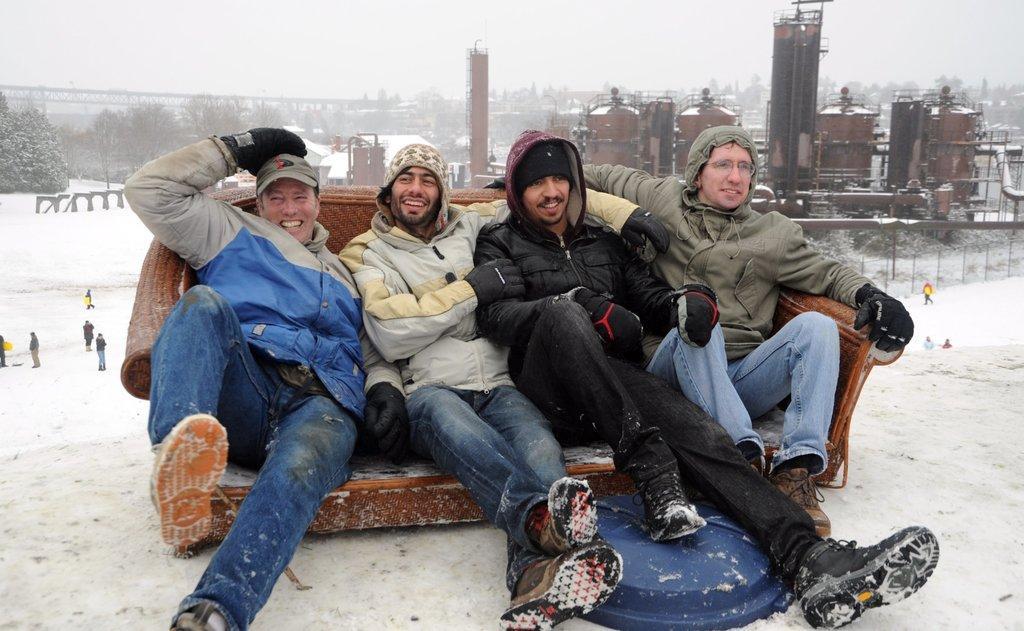In one or two sentences, can you explain what this image depicts? In this picture we can see four men smiling, sitting on a chair and at the back of them we can see some people are standing on sand, containers, trees, some objects and in the background we can see the sky. 